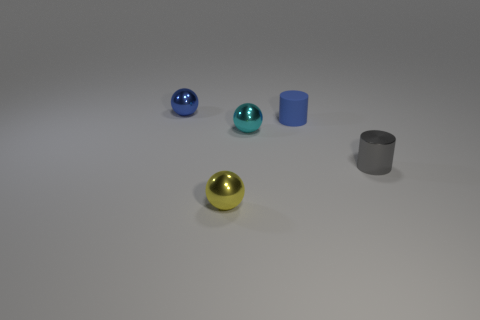Add 1 blue metallic spheres. How many objects exist? 6 Subtract all balls. How many objects are left? 2 Subtract all gray rubber balls. Subtract all balls. How many objects are left? 2 Add 5 small blue things. How many small blue things are left? 7 Add 3 blue rubber objects. How many blue rubber objects exist? 4 Subtract 1 blue cylinders. How many objects are left? 4 